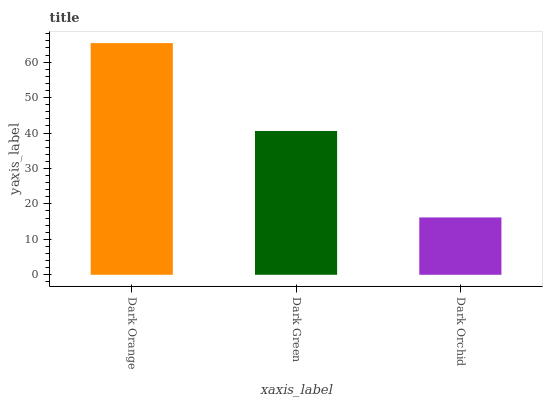Is Dark Orchid the minimum?
Answer yes or no. Yes. Is Dark Orange the maximum?
Answer yes or no. Yes. Is Dark Green the minimum?
Answer yes or no. No. Is Dark Green the maximum?
Answer yes or no. No. Is Dark Orange greater than Dark Green?
Answer yes or no. Yes. Is Dark Green less than Dark Orange?
Answer yes or no. Yes. Is Dark Green greater than Dark Orange?
Answer yes or no. No. Is Dark Orange less than Dark Green?
Answer yes or no. No. Is Dark Green the high median?
Answer yes or no. Yes. Is Dark Green the low median?
Answer yes or no. Yes. Is Dark Orchid the high median?
Answer yes or no. No. Is Dark Orchid the low median?
Answer yes or no. No. 